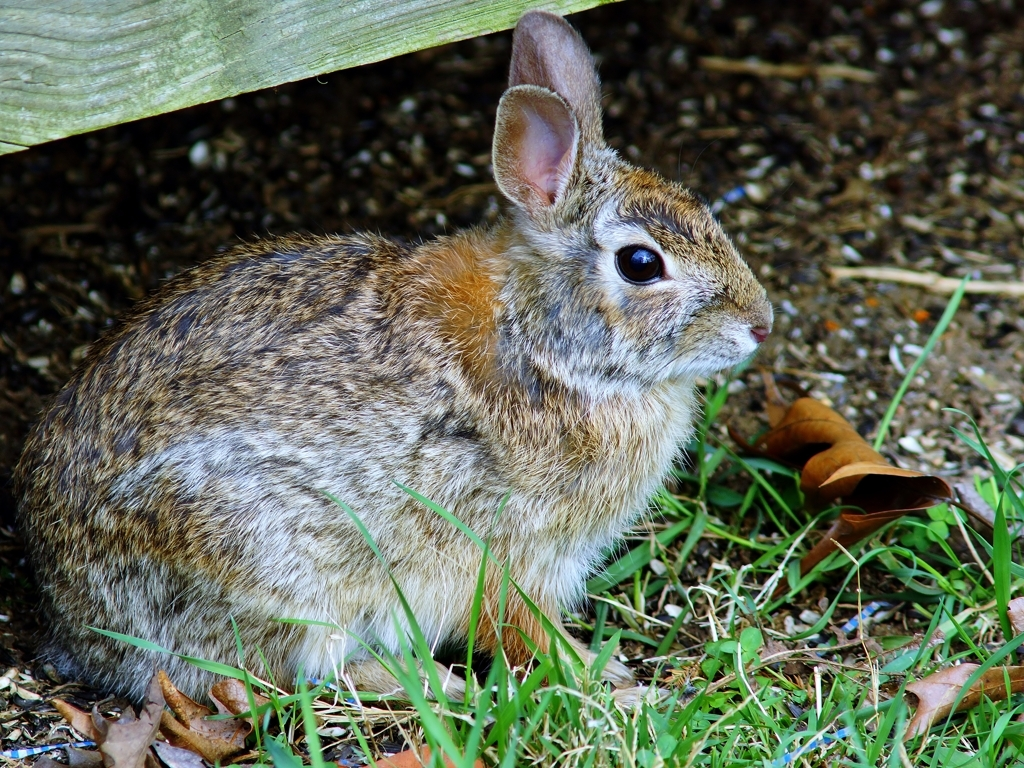What species of rabbit is this, and how can you identify it? This appears to be an Eastern Cottontail rabbit, identifiable by its rounded ears, the pattern and coloration of its fur, and the characteristic white fluffy tail, which is not clearly visible but can be inferred from the species. 